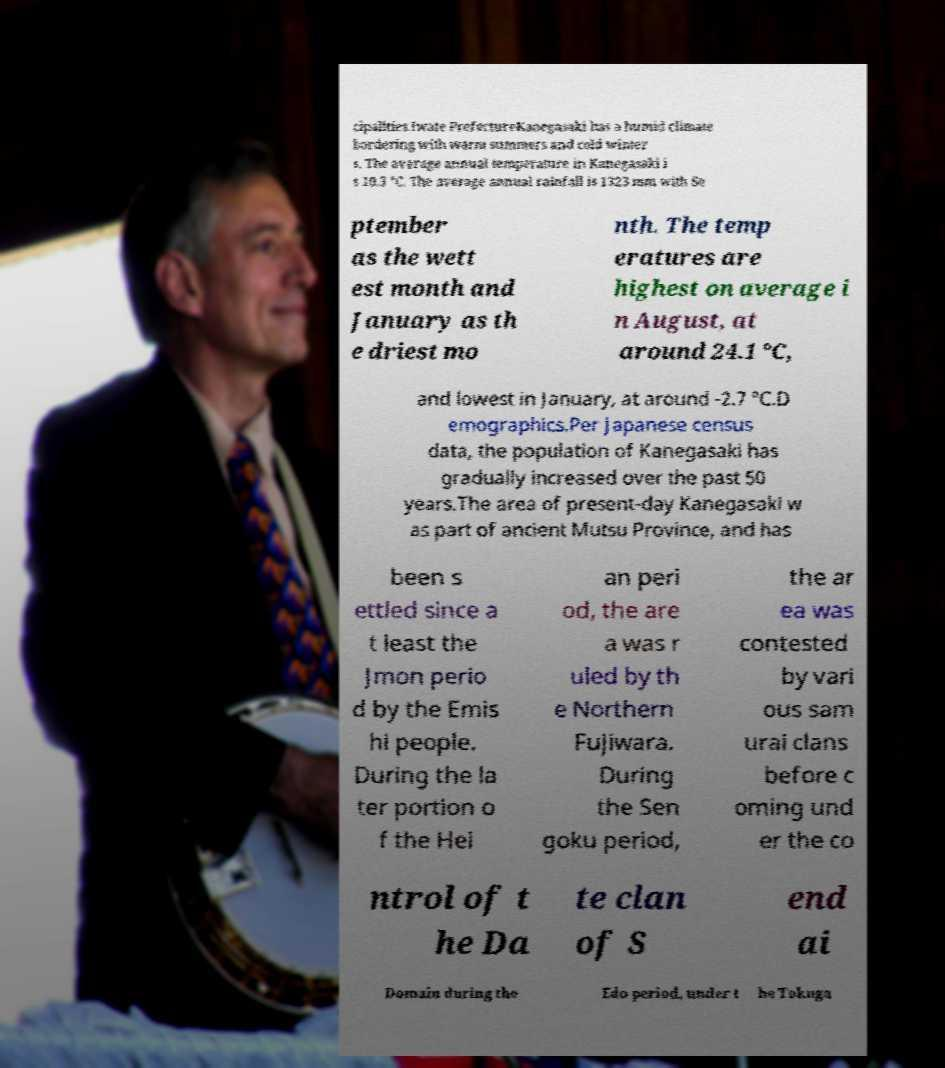Could you assist in decoding the text presented in this image and type it out clearly? cipalities.Iwate PrefectureKanegasaki has a humid climate bordering with warm summers and cold winter s. The average annual temperature in Kanegasaki i s 10.3 °C. The average annual rainfall is 1323 mm with Se ptember as the wett est month and January as th e driest mo nth. The temp eratures are highest on average i n August, at around 24.1 °C, and lowest in January, at around -2.7 °C.D emographics.Per Japanese census data, the population of Kanegasaki has gradually increased over the past 50 years.The area of present-day Kanegasaki w as part of ancient Mutsu Province, and has been s ettled since a t least the Jmon perio d by the Emis hi people. During the la ter portion o f the Hei an peri od, the are a was r uled by th e Northern Fujiwara. During the Sen goku period, the ar ea was contested by vari ous sam urai clans before c oming und er the co ntrol of t he Da te clan of S end ai Domain during the Edo period, under t he Tokuga 